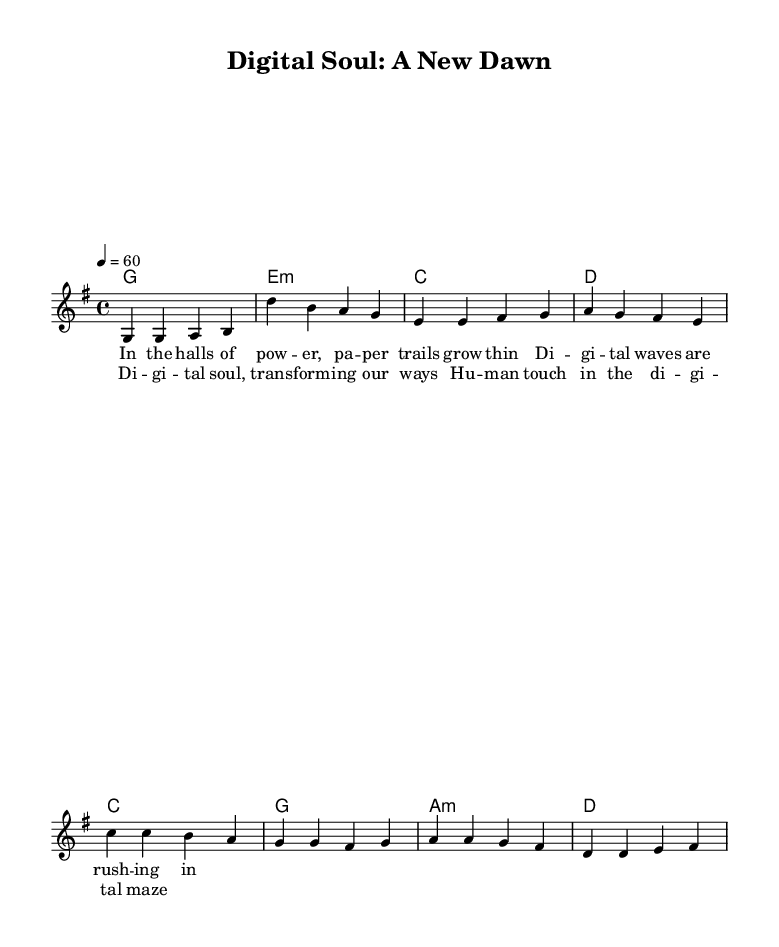What is the key signature of this music? The key signature is G major, which contains one sharp (F#). This can be identified by looking at the key signature section of the sheet music.
Answer: G major What is the time signature of this music? The time signature is 4/4, which indicates four beats per measure and a quarter note receives one beat. This can be found in the time signature notation near the beginning of the sheet music.
Answer: 4/4 What is the tempo marking for this piece? The tempo marking indicates that the piece should be played at a speed of 60 beats per minute, denoted by '4 = 60'. This shows how fast the music should be played.
Answer: 60 How many measures are in the verse? The verse contains 4 measures as seen from the grouping of notes that span 4 units in the harmony, with each corresponding to a measure in the vocal line.
Answer: 4 What is the first note of the melody in the chorus? The first note of the melody in the chorus is C, which can be identified from the melody line just after the verse section.
Answer: C Name the chord used in the first measure of the verse. The chord in the first measure of the verse is G major, as indicated in the chord symbols above the melody which align with the musical phrases.
Answer: G What theme does this music explore in its lyrics? The lyrics explore the theme of digital transformation and its human aspects, focusing on the emotional connection amidst technology changes, which is a common theme in soul music.
Answer: Digital transformation 